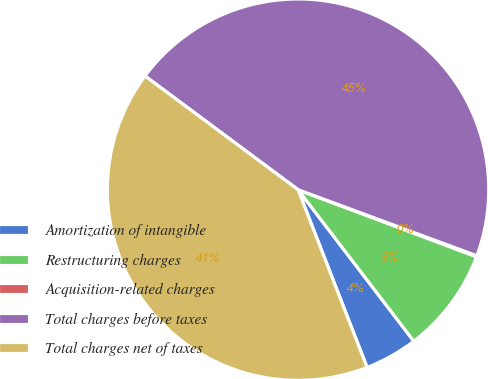Convert chart to OTSL. <chart><loc_0><loc_0><loc_500><loc_500><pie_chart><fcel>Amortization of intangible<fcel>Restructuring charges<fcel>Acquisition-related charges<fcel>Total charges before taxes<fcel>Total charges net of taxes<nl><fcel>4.49%<fcel>8.89%<fcel>0.09%<fcel>45.47%<fcel>41.07%<nl></chart> 